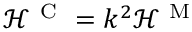Convert formula to latex. <formula><loc_0><loc_0><loc_500><loc_500>\mathcal { H } ^ { C } = k ^ { 2 } \mathcal { H } ^ { M }</formula> 